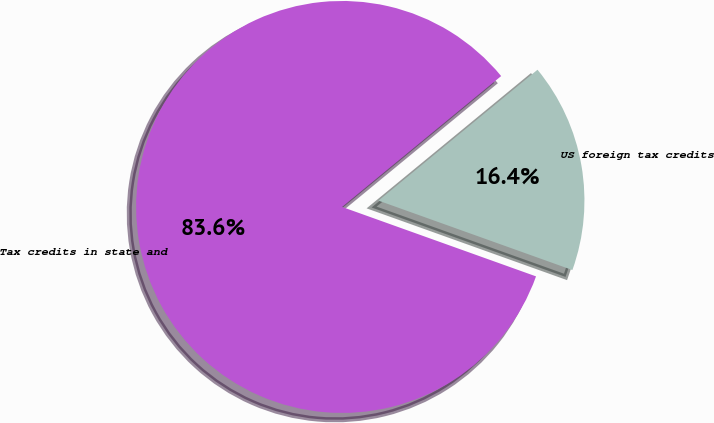Convert chart. <chart><loc_0><loc_0><loc_500><loc_500><pie_chart><fcel>US foreign tax credits<fcel>Tax credits in state and<nl><fcel>16.43%<fcel>83.57%<nl></chart> 